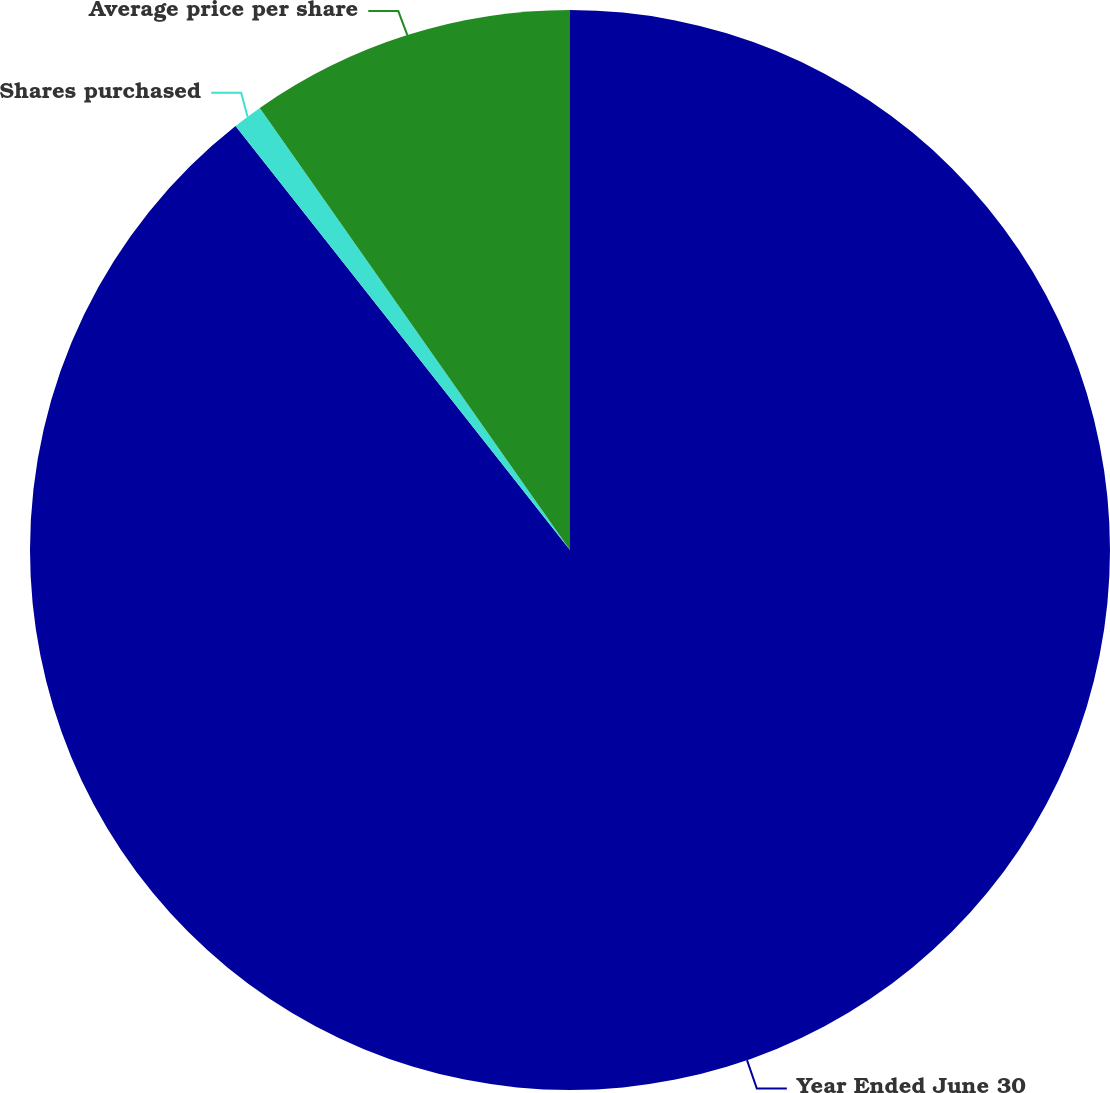<chart> <loc_0><loc_0><loc_500><loc_500><pie_chart><fcel>Year Ended June 30<fcel>Shares purchased<fcel>Average price per share<nl><fcel>89.37%<fcel>0.89%<fcel>9.74%<nl></chart> 